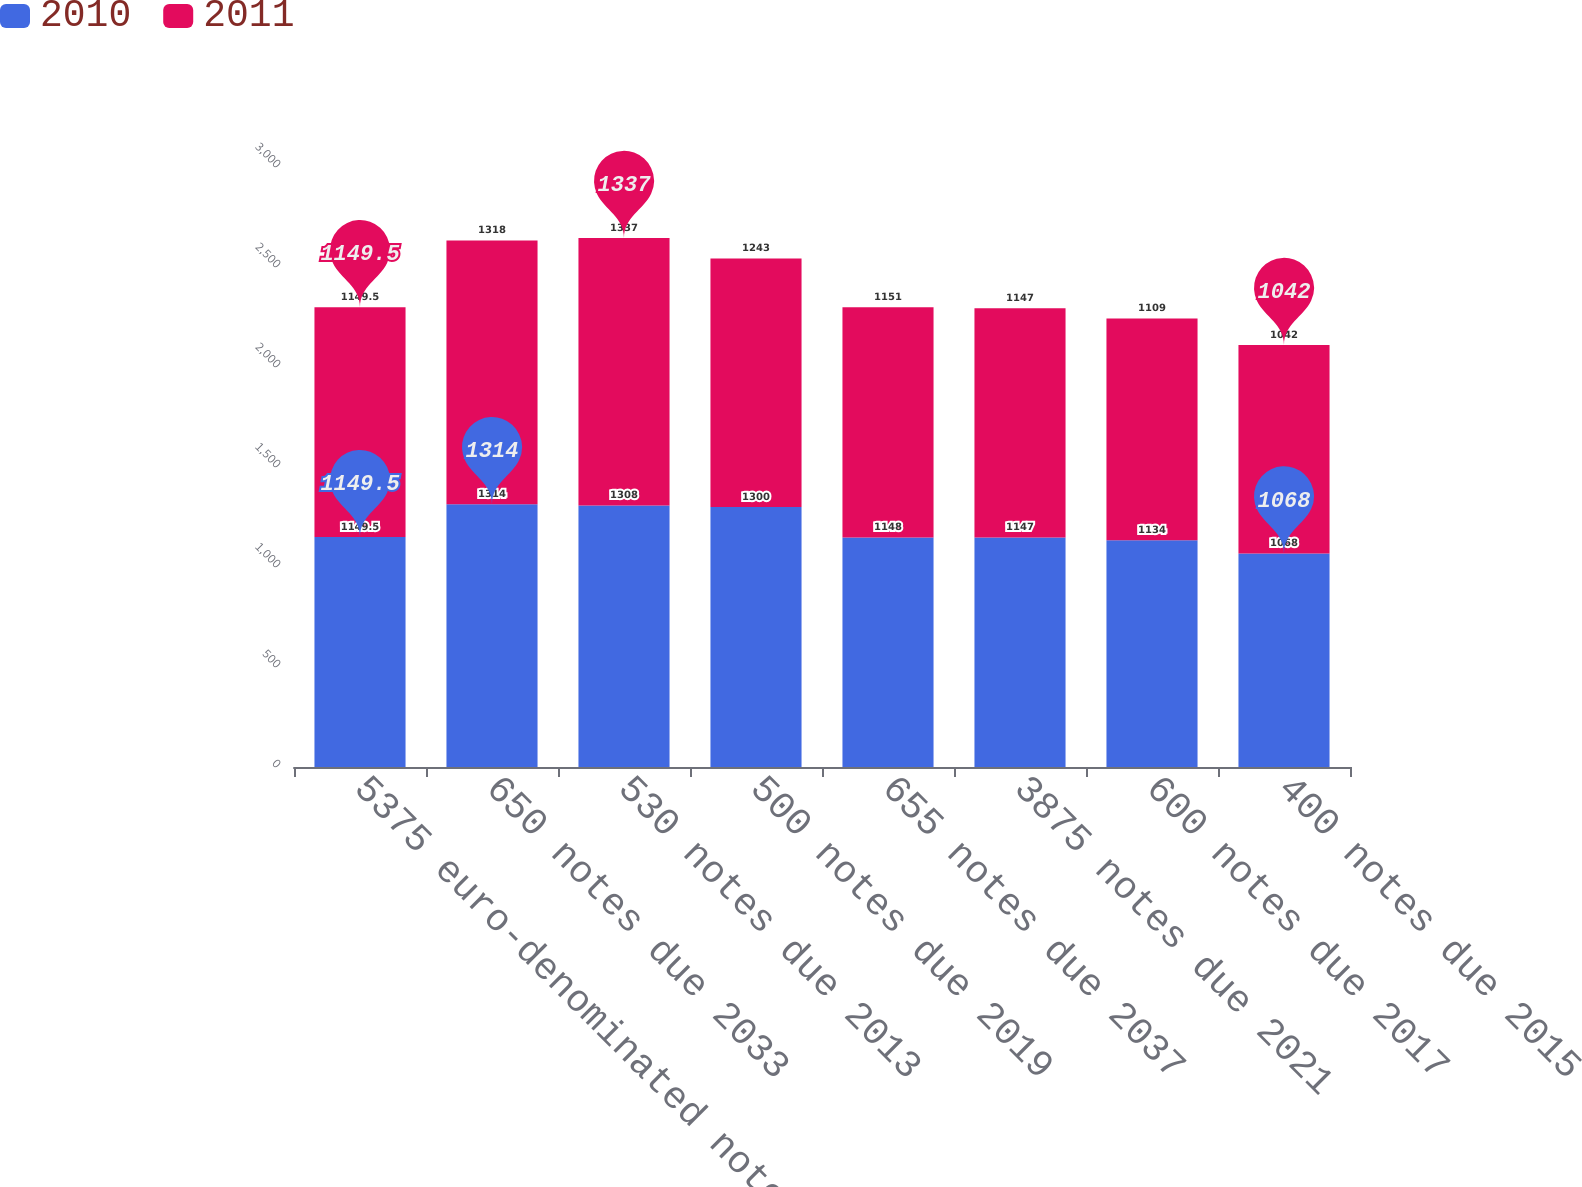Convert chart. <chart><loc_0><loc_0><loc_500><loc_500><stacked_bar_chart><ecel><fcel>5375 euro-denominated notes<fcel>650 notes due 2033<fcel>530 notes due 2013<fcel>500 notes due 2019<fcel>655 notes due 2037<fcel>3875 notes due 2021<fcel>600 notes due 2017<fcel>400 notes due 2015<nl><fcel>2010<fcel>1149.5<fcel>1314<fcel>1308<fcel>1300<fcel>1148<fcel>1147<fcel>1134<fcel>1068<nl><fcel>2011<fcel>1149.5<fcel>1318<fcel>1337<fcel>1243<fcel>1151<fcel>1147<fcel>1109<fcel>1042<nl></chart> 